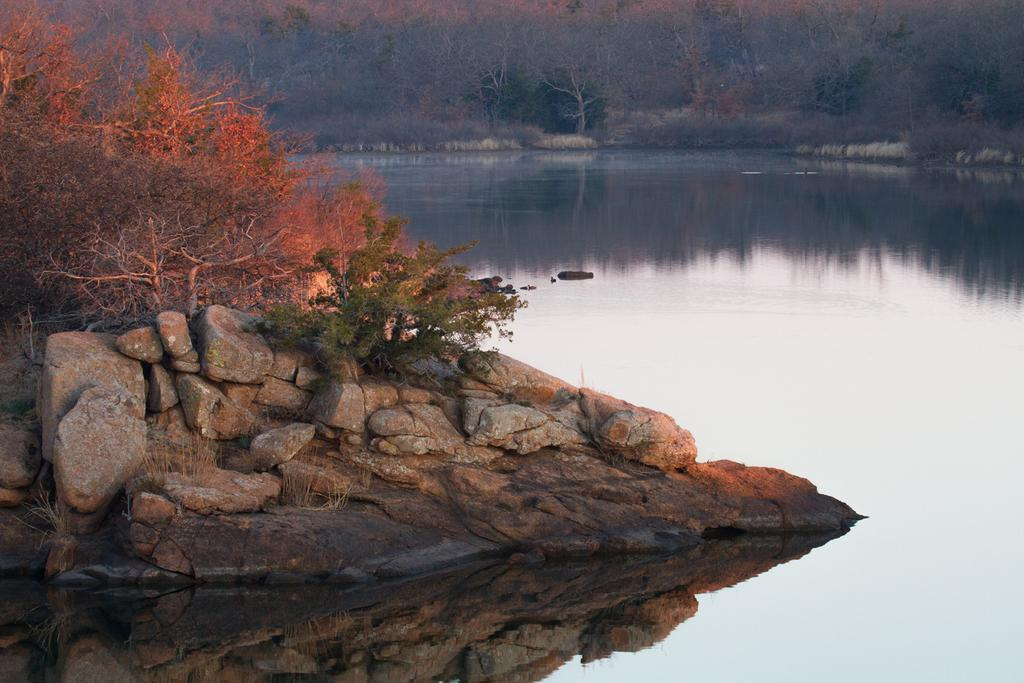What can be seen on the left side of the image? There are stones and trees on the left side of the image. What is present on the right side of the image? There are trees, plants, and water visible on the right side of the image. Which actor is performing in the image? There are no actors or performances present in the image; it features natural elements such as stones, trees, plants, and water. What type of experience can be gained from the image? The image itself does not offer an experience, but it may evoke feelings or thoughts related to nature or landscapes. 